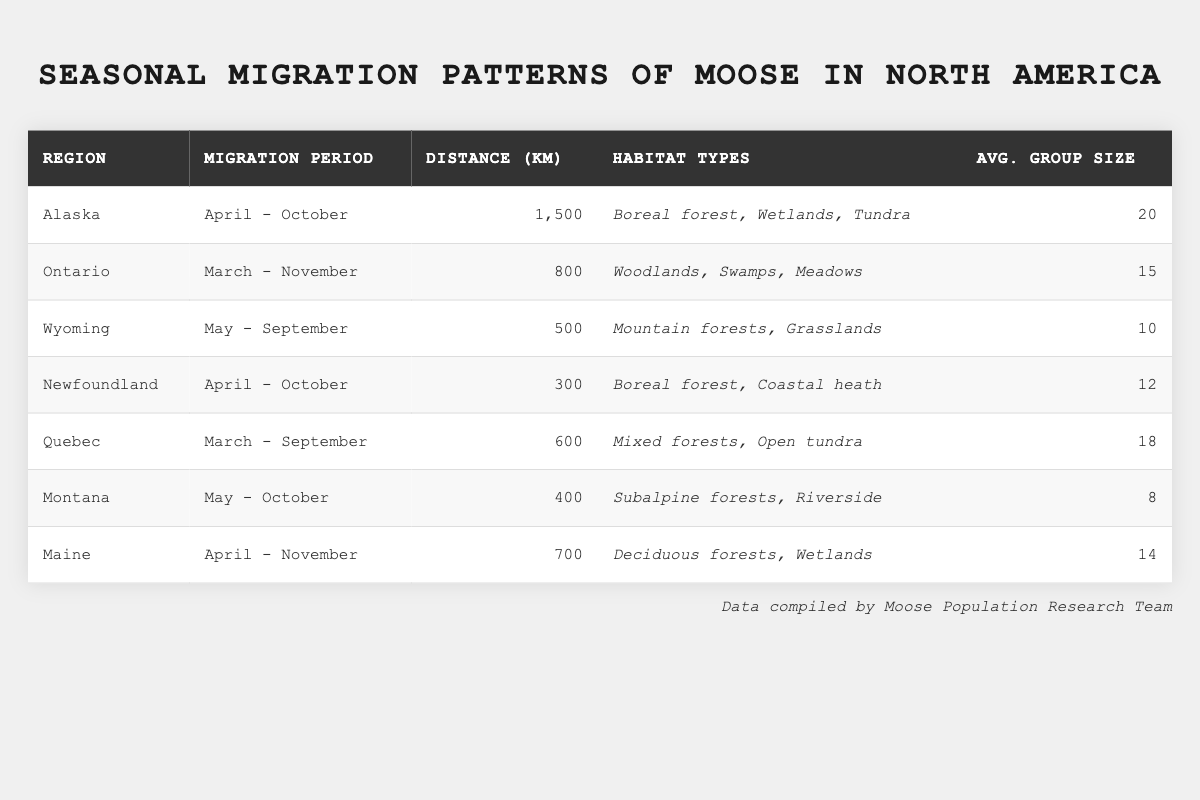What is the migration period for moose in Ontario? The table indicates that moose in Ontario migrate from March to November.
Answer: March - November What is the distance traveled by moose in Alaska? The table states that the distance traveled by moose in Alaska is 1,500 km.
Answer: 1,500 km How many average group members migrate together in Quebec? According to the table, the average group size for moose in Quebec is 18.
Answer: 18 Which region has the shortest migration distance? The table shows that Newfoundland has the shortest migration distance of 300 km.
Answer: Newfoundland Calculate the average migration distance for all regions listed in the table. The distances are 1,500, 800, 500, 300, 600, 400, and 700 km, which sum to 4,800 km. Since there are 7 regions, the average is 4,800 km / 7 = 685.71 km.
Answer: 685.71 km Is the average group size in Wyoming greater than or equal to that in Maine? The table shows that Wyoming has an average group size of 10, while Maine has 14. Since 10 is less than 14, the answer is no.
Answer: No Which region(s) have a migration period that ends in October? According to the table, both Alaska and Montana have migration periods that end in October.
Answer: Alaska, Montana What is the total average group size of moose across all regions? The average group sizes are 20, 15, 10, 12, 18, 8, and 14. Adding these gives a total of 97, which when divided by 7 regions equals approximately 13.86.
Answer: 13.86 Which habitat type is common in both Alaska and Newfoundland? Both Alaska and Newfoundland list "Boreal forest" as a habitat type in the table.
Answer: Boreal forest Do moose in Wyoming migrate during the same period as those in Quebec? The table shows that Wyoming migrates from May to September, while Quebec migrates from March to September. Since their periods overlap in September, the answer is yes.
Answer: Yes 